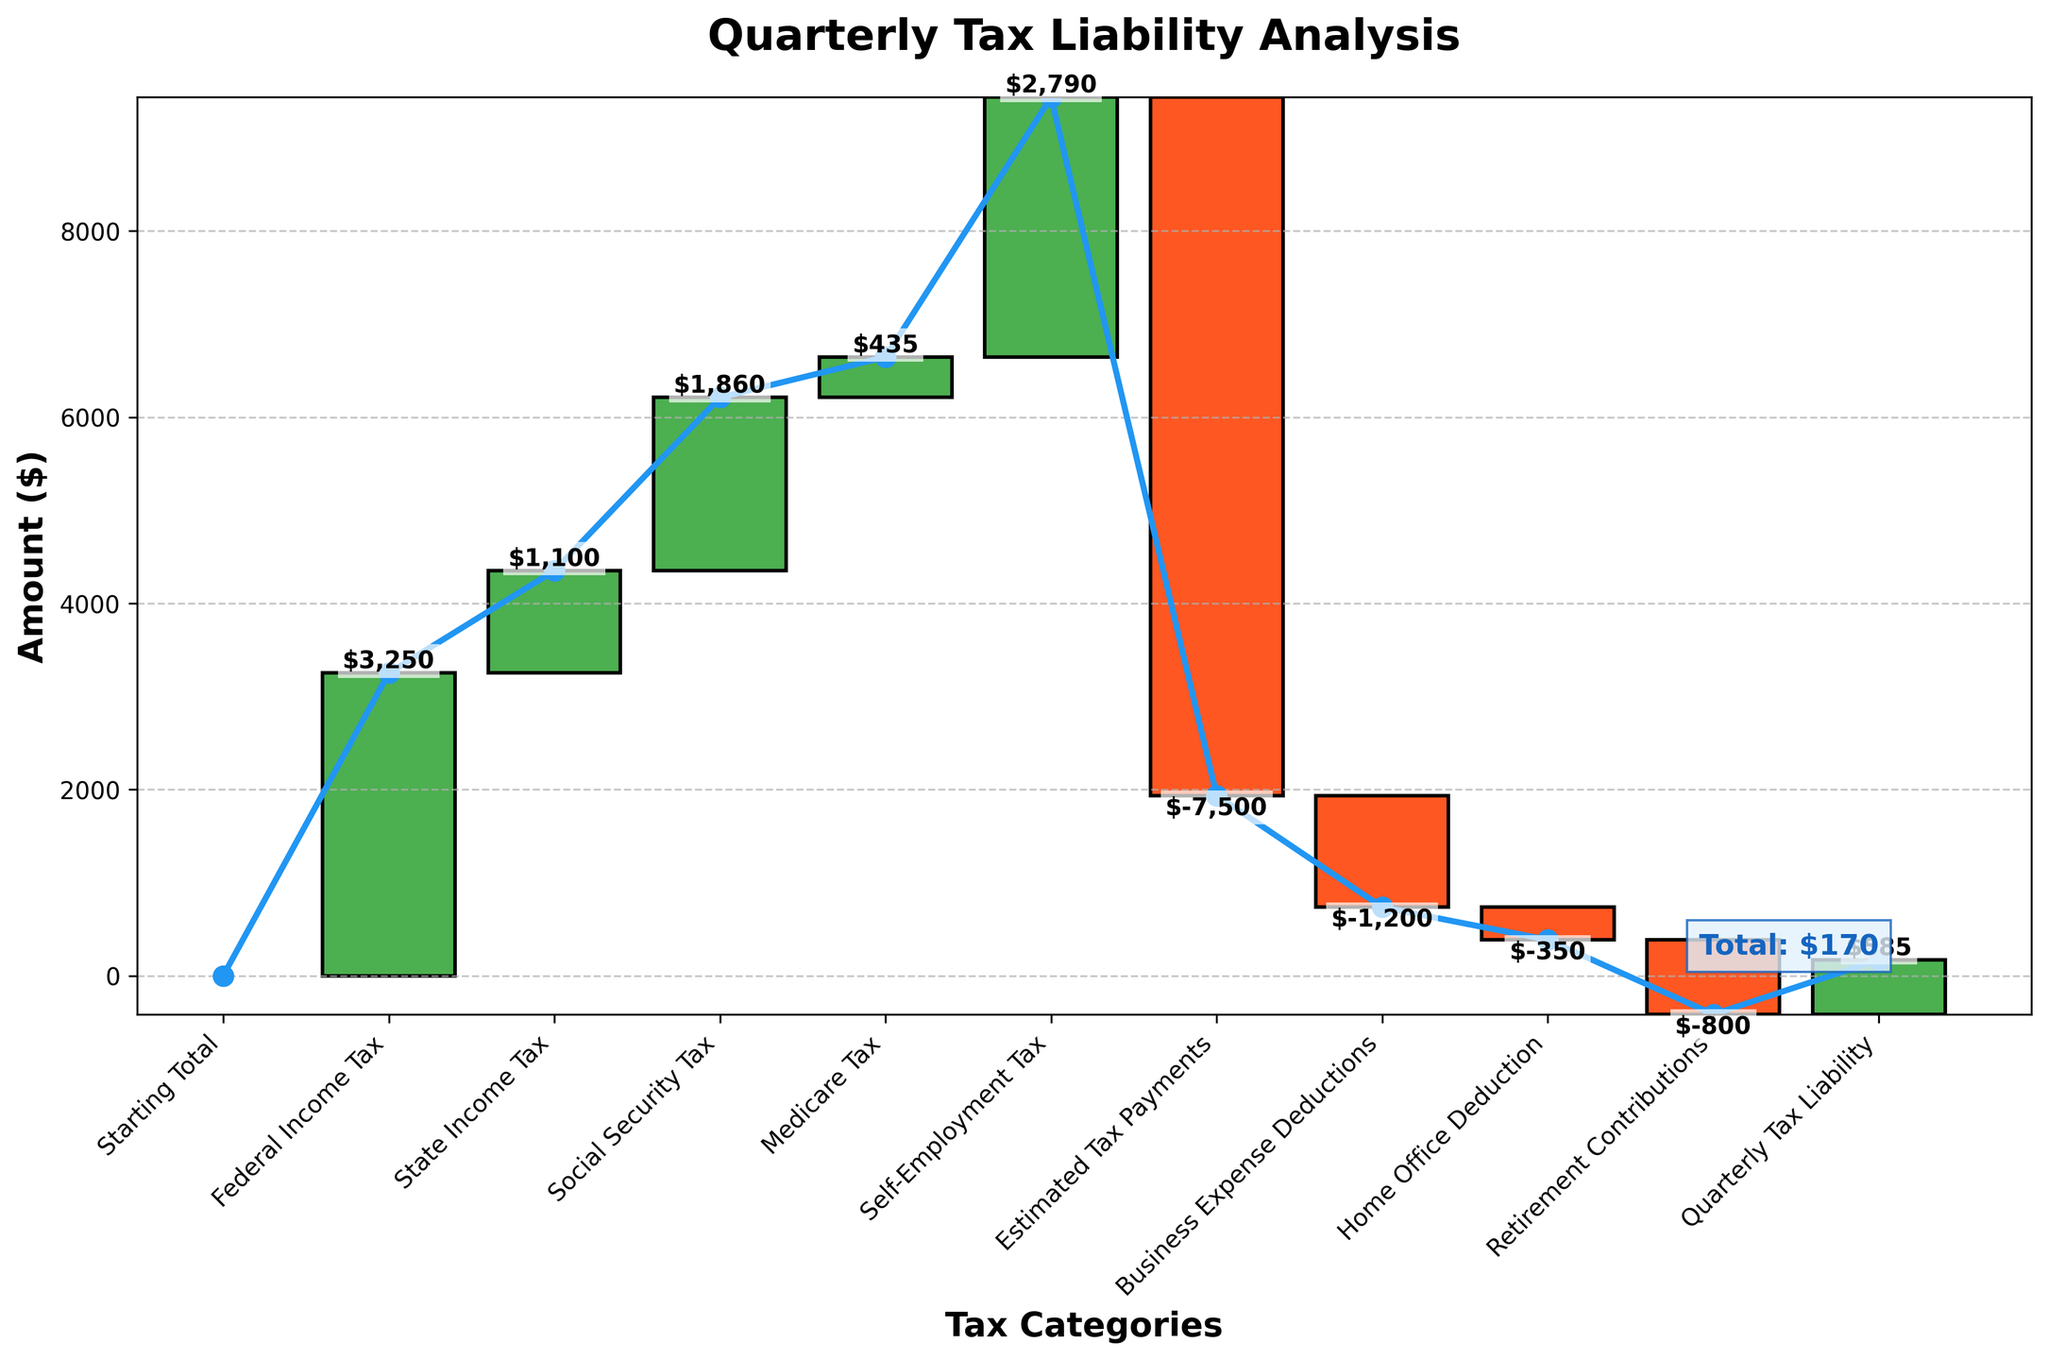What is the title of the chart? The title is located at the top of the figure and is generally used to describe the primary subject of the chart.
Answer: Quarterly Tax Liability Analysis How many tax categories are shown in the chart? Count the number of categories listed on the x-axis excluding the "Starting Total".
Answer: 10 Which tax category has the highest positive contribution to the tax liability? Identify the category with the tallest green bar pointing upwards.
Answer: Federal Income Tax What is the total impact of tax categories leading to "Quarterly Tax Liability"? Add up all the positive and negative amounts displayed in the chart to find how the final total is reached.
Answer: $585 What is the amount for "Estimated Tax Payments"? Locate the bar labeled "Estimated Tax Payments" and note the value associated with it.
Answer: -$7,500 How does the value of "Federal Income Tax" compare to "State Income Tax"? Compare the height/amount of the bars for "Federal Income Tax" and "State Income Tax".
Answer: Federal Income Tax is higher Which deduction category reduces the tax liability the most? Among the categories with negative contributions, identify the one with the lowest value.
Answer: Business Expense Deductions What is the cumulative amount just before "Quarterly Tax Liability"? The cumulative amount right before the final step shows the total deductions and taxes considered up to that point.
Answer: $-585 How much does "Self-Employment Tax" add to the tax liability? Locate the bar labeled "Self-Employment Tax" and note the value.
Answer: $2790 Estimate the cumulative tax liability after accounting for "Social Security Tax". Sum up the amounts from the "Starting Total", "Federal Income Tax", "State Income Tax", and "Social Security Tax".
Answer: $6210 